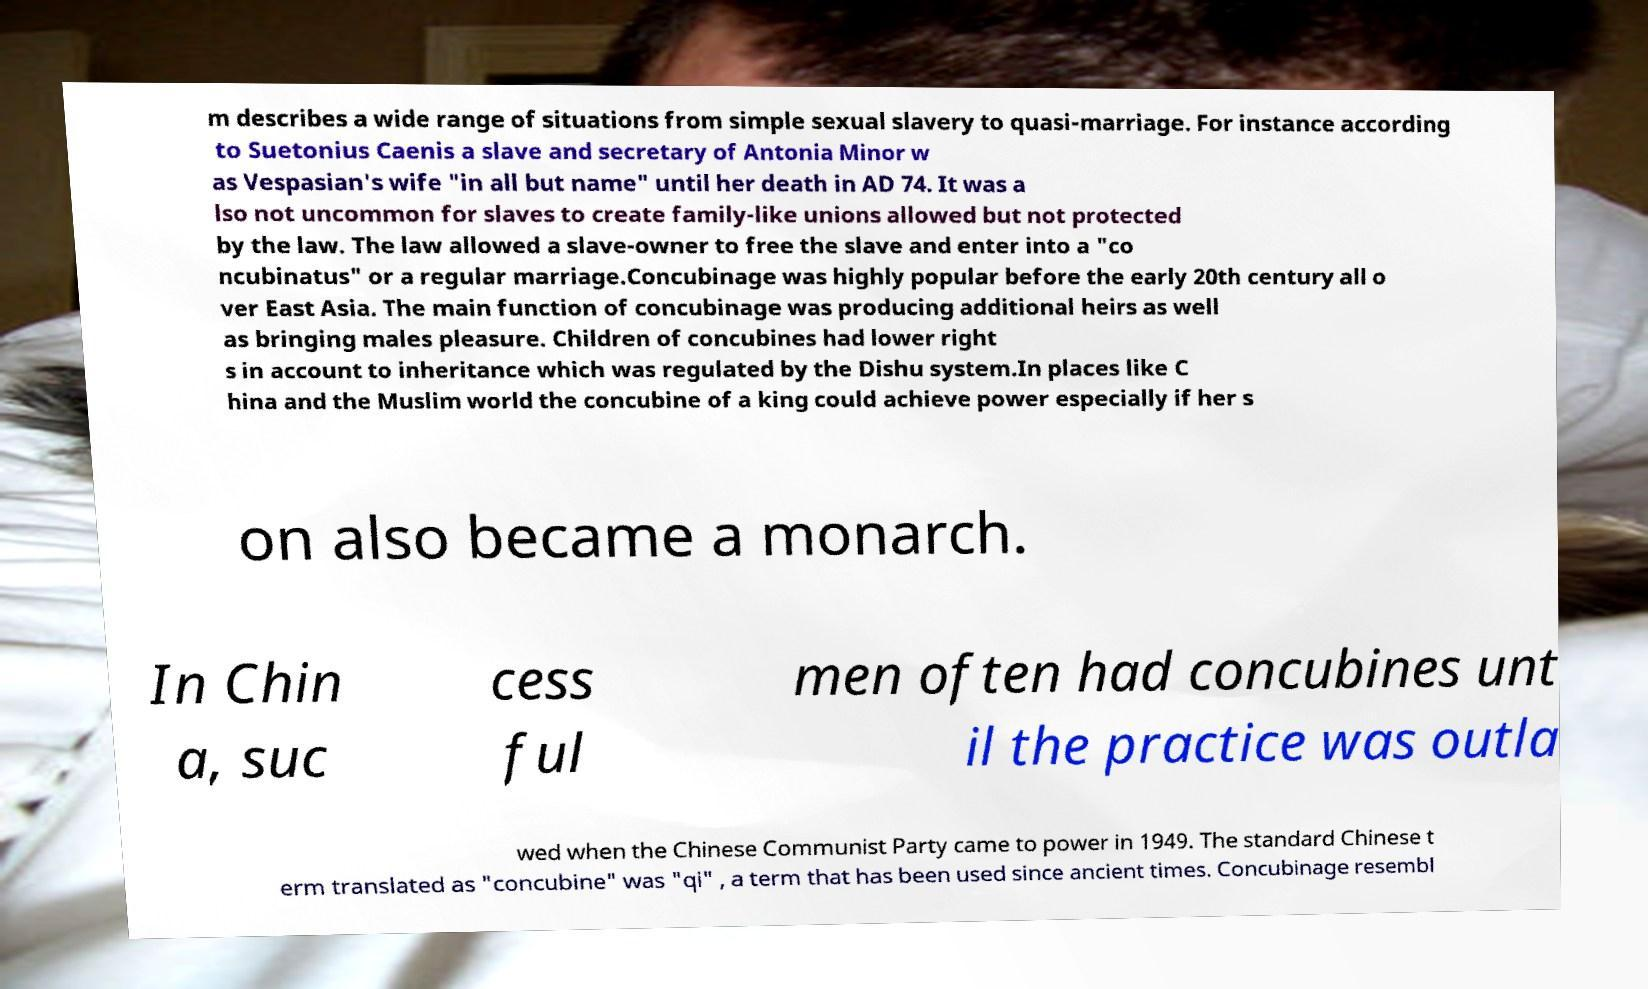For documentation purposes, I need the text within this image transcribed. Could you provide that? m describes a wide range of situations from simple sexual slavery to quasi-marriage. For instance according to Suetonius Caenis a slave and secretary of Antonia Minor w as Vespasian's wife "in all but name" until her death in AD 74. It was a lso not uncommon for slaves to create family-like unions allowed but not protected by the law. The law allowed a slave-owner to free the slave and enter into a "co ncubinatus" or a regular marriage.Concubinage was highly popular before the early 20th century all o ver East Asia. The main function of concubinage was producing additional heirs as well as bringing males pleasure. Children of concubines had lower right s in account to inheritance which was regulated by the Dishu system.In places like C hina and the Muslim world the concubine of a king could achieve power especially if her s on also became a monarch. In Chin a, suc cess ful men often had concubines unt il the practice was outla wed when the Chinese Communist Party came to power in 1949. The standard Chinese t erm translated as "concubine" was "qi" , a term that has been used since ancient times. Concubinage resembl 